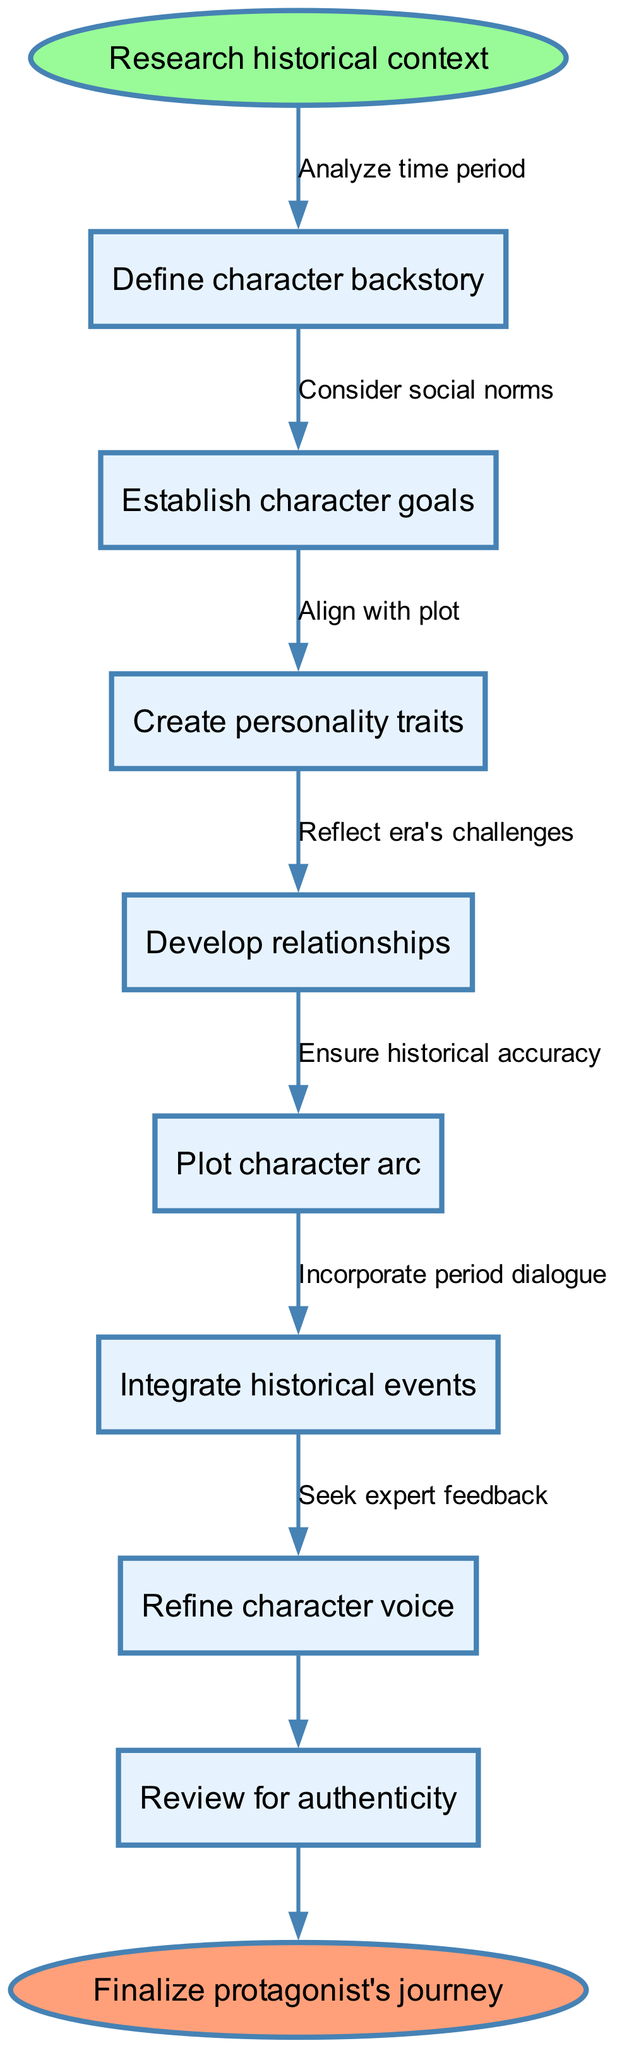What is the starting node of the character development journey? The diagram indicates that the journey begins with the node labeled "Research historical context." This is the first node connected to the start of the flow chart.
Answer: Research historical context How many nodes are present in the diagram? There are 8 nodes in total. This includes the starting node, the 7 character development-related nodes, and the end node. Counting all of these gives a total of 8.
Answer: 8 What is the end node of this flow chart? The flow chart concludes with the end node labeled "Finalize protagonist's journey." This marks the completion of the character development process.
Answer: Finalize protagonist's journey Which node comes immediately after "Define character backstory"? The node that comes immediately after "Define character backstory" is "Establish character goals." This connection reflects the flow of character development in sequence.
Answer: Establish character goals What is the relationship between "Create personality traits" and "Plot character arc"? The relationship between "Create personality traits" and "Plot character arc" is an edge that connects them, implying a sequential development process. "Create personality traits" feeds into the formulation of the "Plot character arc."
Answer: Edge connection What is one instruction before refining the character voice? One instruction that precedes the "Refine character voice" node is "Develop relationships." This indicates that understanding relationships comes before fine-tuning the voice of the character.
Answer: Develop relationships What instruction correlates with integrating historical events? The instruction that correlates with "Integrate historical events" would be "Align with plot." This means that historical events should seamlessly fit into the overarching storyline.
Answer: Align with plot What step from the edges should be considered to ensure historical accuracy? To ensure historical accuracy, one should consider "Seek expert feedback," which is an action that supports the authenticity of the character's representation in the historical context.
Answer: Seek expert feedback 